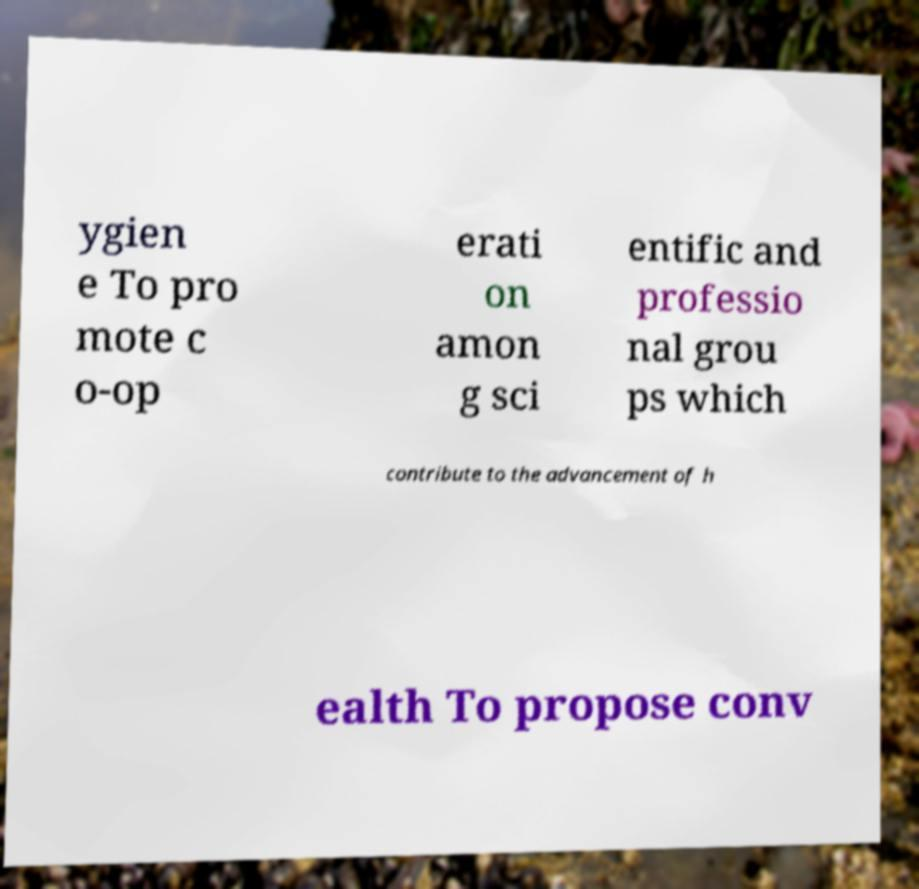Can you read and provide the text displayed in the image?This photo seems to have some interesting text. Can you extract and type it out for me? ygien e To pro mote c o-op erati on amon g sci entific and professio nal grou ps which contribute to the advancement of h ealth To propose conv 